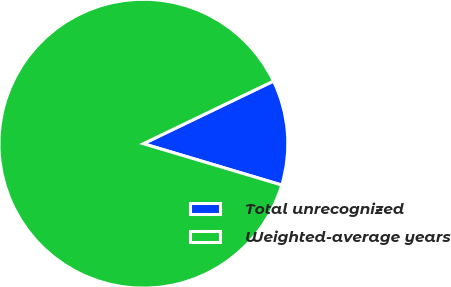Convert chart to OTSL. <chart><loc_0><loc_0><loc_500><loc_500><pie_chart><fcel>Total unrecognized<fcel>Weighted-average years<nl><fcel>11.76%<fcel>88.24%<nl></chart> 